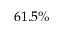Convert formula to latex. <formula><loc_0><loc_0><loc_500><loc_500>6 1 . 5 \%</formula> 